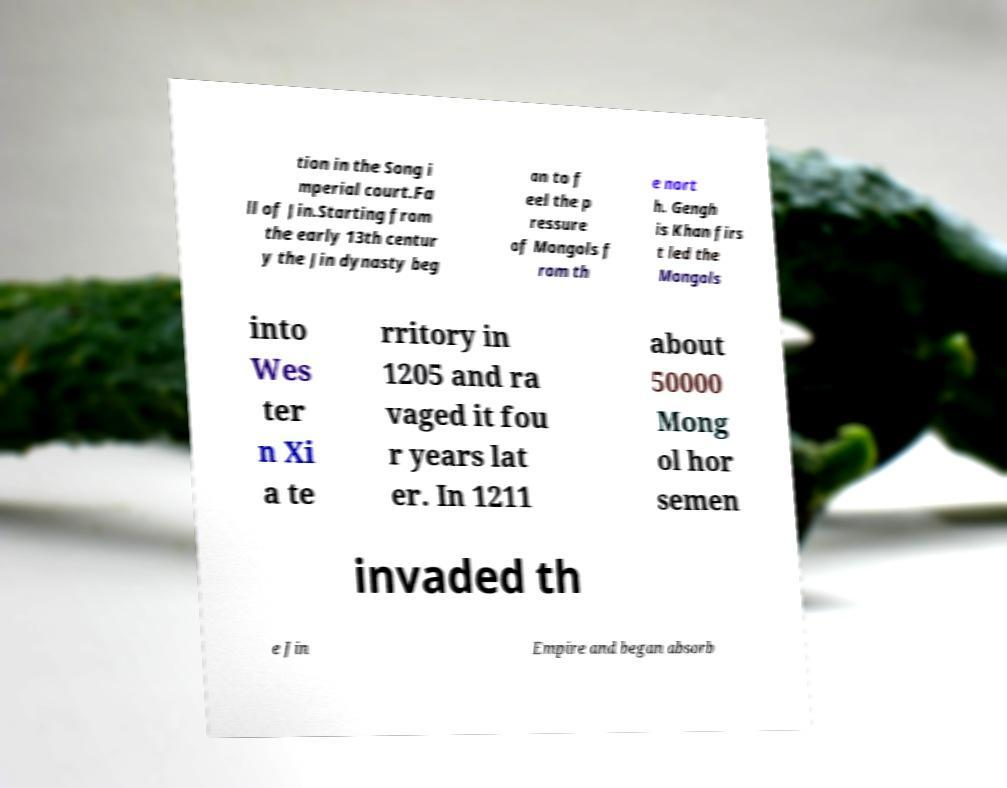What messages or text are displayed in this image? I need them in a readable, typed format. tion in the Song i mperial court.Fa ll of Jin.Starting from the early 13th centur y the Jin dynasty beg an to f eel the p ressure of Mongols f rom th e nort h. Gengh is Khan firs t led the Mongols into Wes ter n Xi a te rritory in 1205 and ra vaged it fou r years lat er. In 1211 about 50000 Mong ol hor semen invaded th e Jin Empire and began absorb 